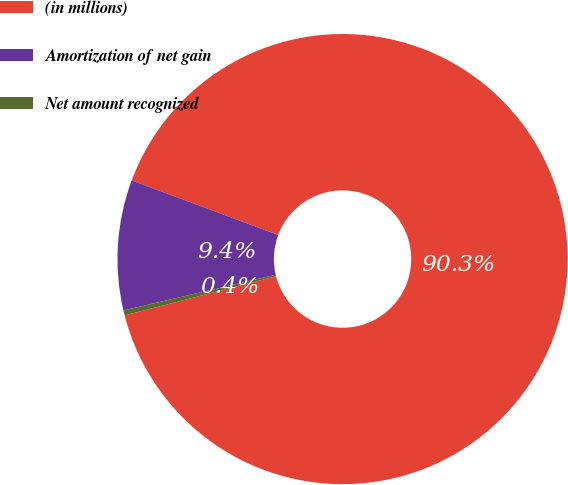Convert chart to OTSL. <chart><loc_0><loc_0><loc_500><loc_500><pie_chart><fcel>(in millions)<fcel>Amortization of net gain<fcel>Net amount recognized<nl><fcel>90.29%<fcel>9.35%<fcel>0.36%<nl></chart> 